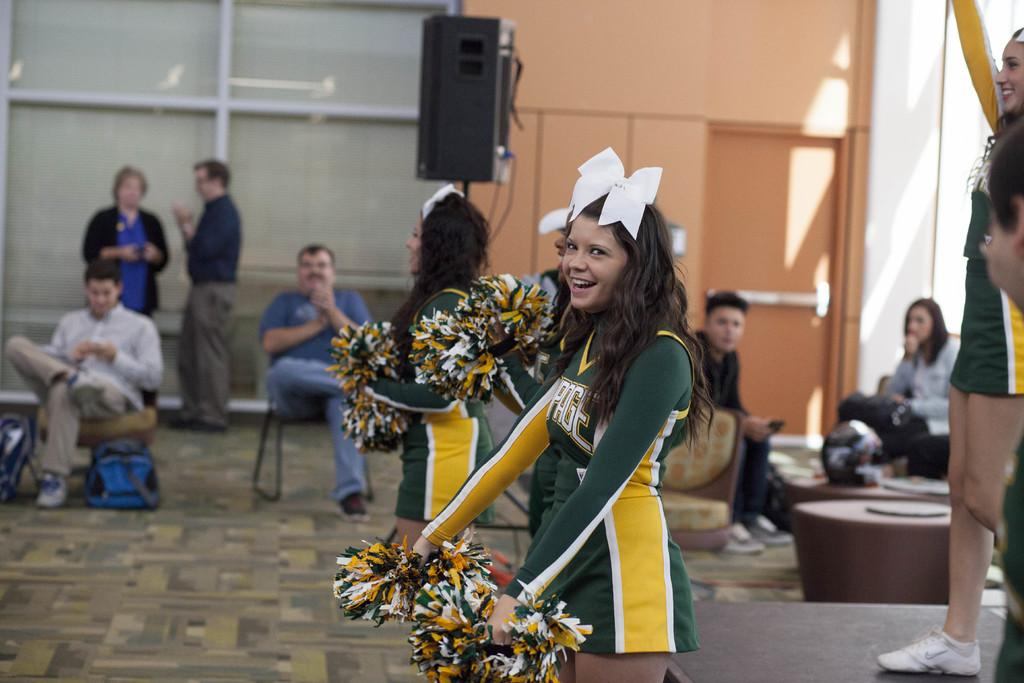What type of people can be seen in the image? There are cheer girls in the image. What are some of the people in the image doing? There are people sitting and standing in the image. What object is present in the image that might be used for amplifying sound? There is a speaker in the image. How many children are participating in the country's representative event in the image? There is no mention of children, a country, or a representative event in the image. 